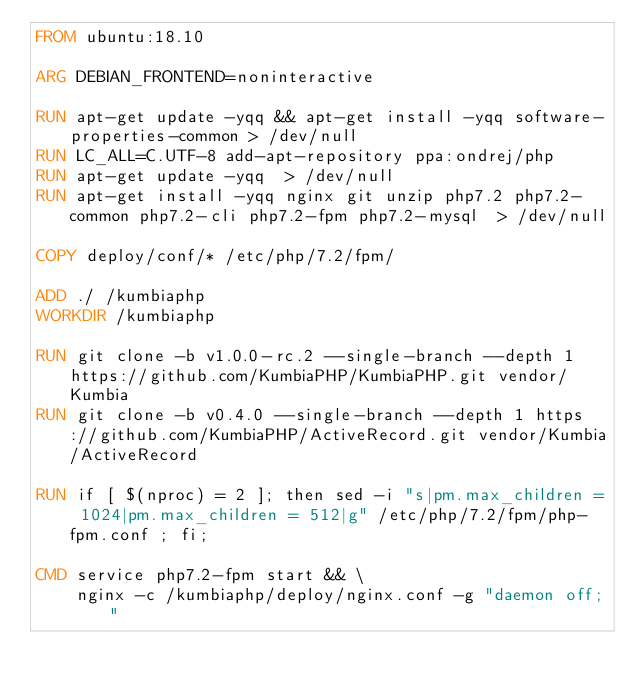Convert code to text. <code><loc_0><loc_0><loc_500><loc_500><_Dockerfile_>FROM ubuntu:18.10

ARG DEBIAN_FRONTEND=noninteractive

RUN apt-get update -yqq && apt-get install -yqq software-properties-common > /dev/null
RUN LC_ALL=C.UTF-8 add-apt-repository ppa:ondrej/php
RUN apt-get update -yqq  > /dev/null
RUN apt-get install -yqq nginx git unzip php7.2 php7.2-common php7.2-cli php7.2-fpm php7.2-mysql  > /dev/null

COPY deploy/conf/* /etc/php/7.2/fpm/

ADD ./ /kumbiaphp
WORKDIR /kumbiaphp

RUN git clone -b v1.0.0-rc.2 --single-branch --depth 1 https://github.com/KumbiaPHP/KumbiaPHP.git vendor/Kumbia
RUN git clone -b v0.4.0 --single-branch --depth 1 https://github.com/KumbiaPHP/ActiveRecord.git vendor/Kumbia/ActiveRecord

RUN if [ $(nproc) = 2 ]; then sed -i "s|pm.max_children = 1024|pm.max_children = 512|g" /etc/php/7.2/fpm/php-fpm.conf ; fi;

CMD service php7.2-fpm start && \
    nginx -c /kumbiaphp/deploy/nginx.conf -g "daemon off;"
</code> 